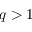Convert formula to latex. <formula><loc_0><loc_0><loc_500><loc_500>q > 1</formula> 